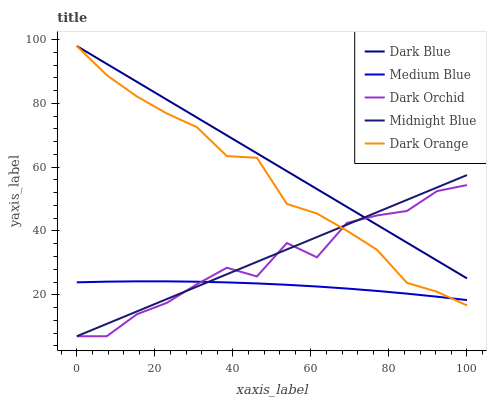Does Medium Blue have the minimum area under the curve?
Answer yes or no. Yes. Does Midnight Blue have the minimum area under the curve?
Answer yes or no. No. Does Midnight Blue have the maximum area under the curve?
Answer yes or no. No. Is Dark Orchid the roughest?
Answer yes or no. Yes. Is Medium Blue the smoothest?
Answer yes or no. No. Is Medium Blue the roughest?
Answer yes or no. No. Does Medium Blue have the lowest value?
Answer yes or no. No. Does Midnight Blue have the highest value?
Answer yes or no. No. Is Medium Blue less than Dark Blue?
Answer yes or no. Yes. Is Dark Blue greater than Medium Blue?
Answer yes or no. Yes. Does Medium Blue intersect Dark Blue?
Answer yes or no. No. 